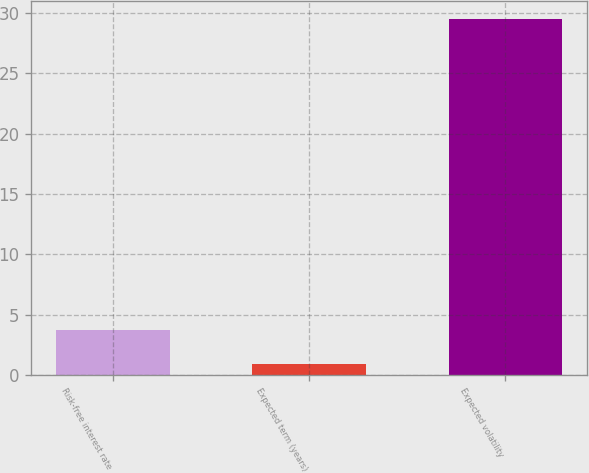Convert chart. <chart><loc_0><loc_0><loc_500><loc_500><bar_chart><fcel>Risk-free interest rate<fcel>Expected term (years)<fcel>Expected volatility<nl><fcel>3.76<fcel>0.9<fcel>29.46<nl></chart> 